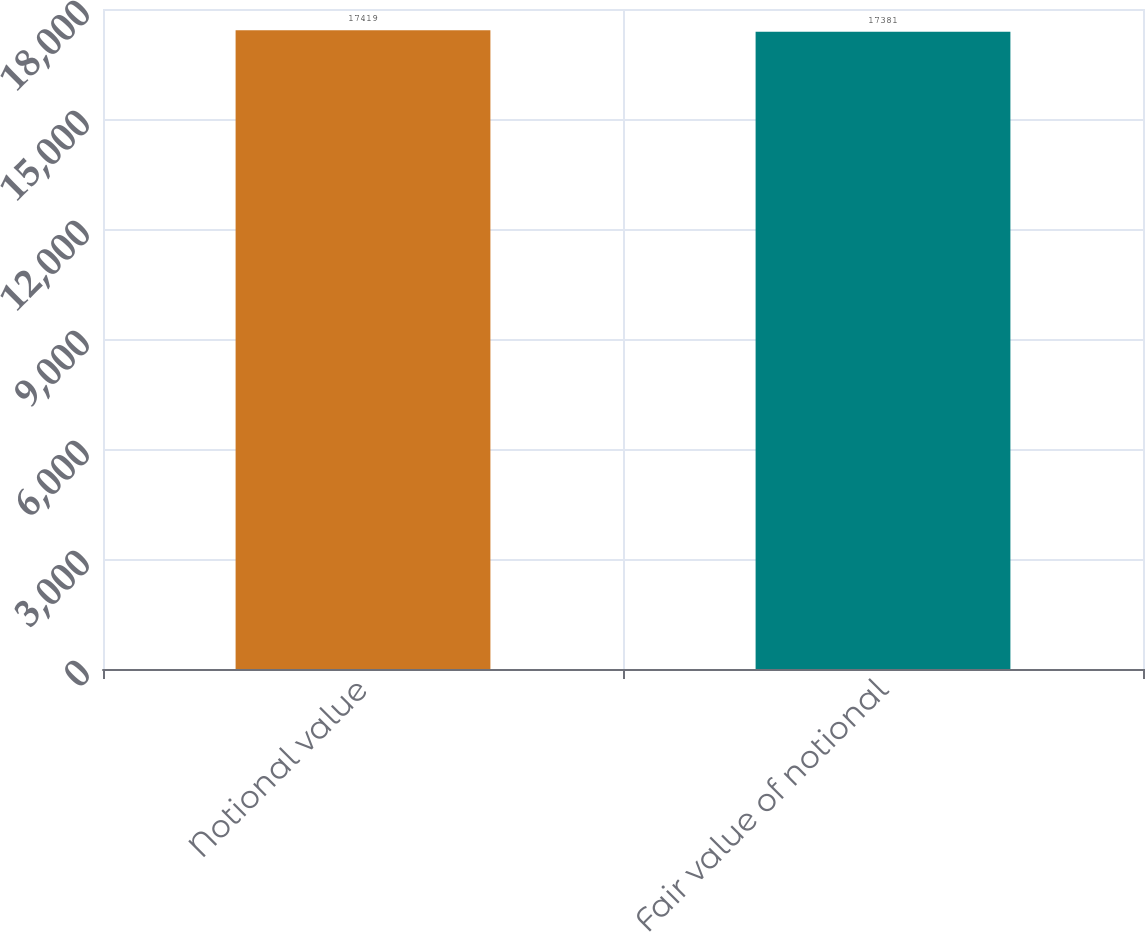<chart> <loc_0><loc_0><loc_500><loc_500><bar_chart><fcel>Notional value<fcel>Fair value of notional<nl><fcel>17419<fcel>17381<nl></chart> 